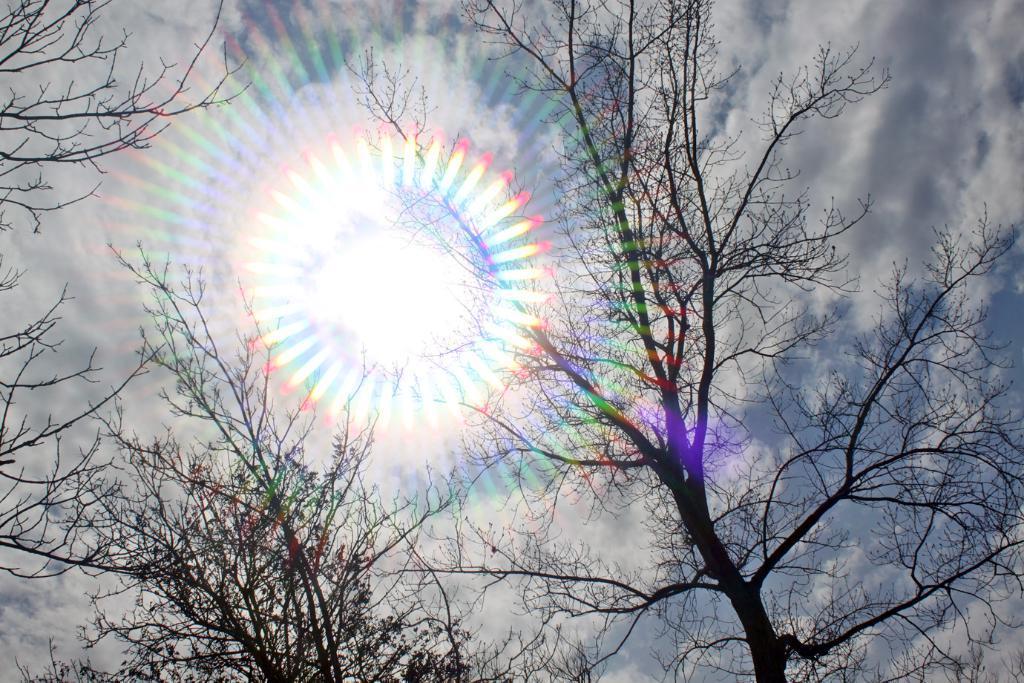Please provide a concise description of this image. In this image I can see trees. There is sun in the sky. 